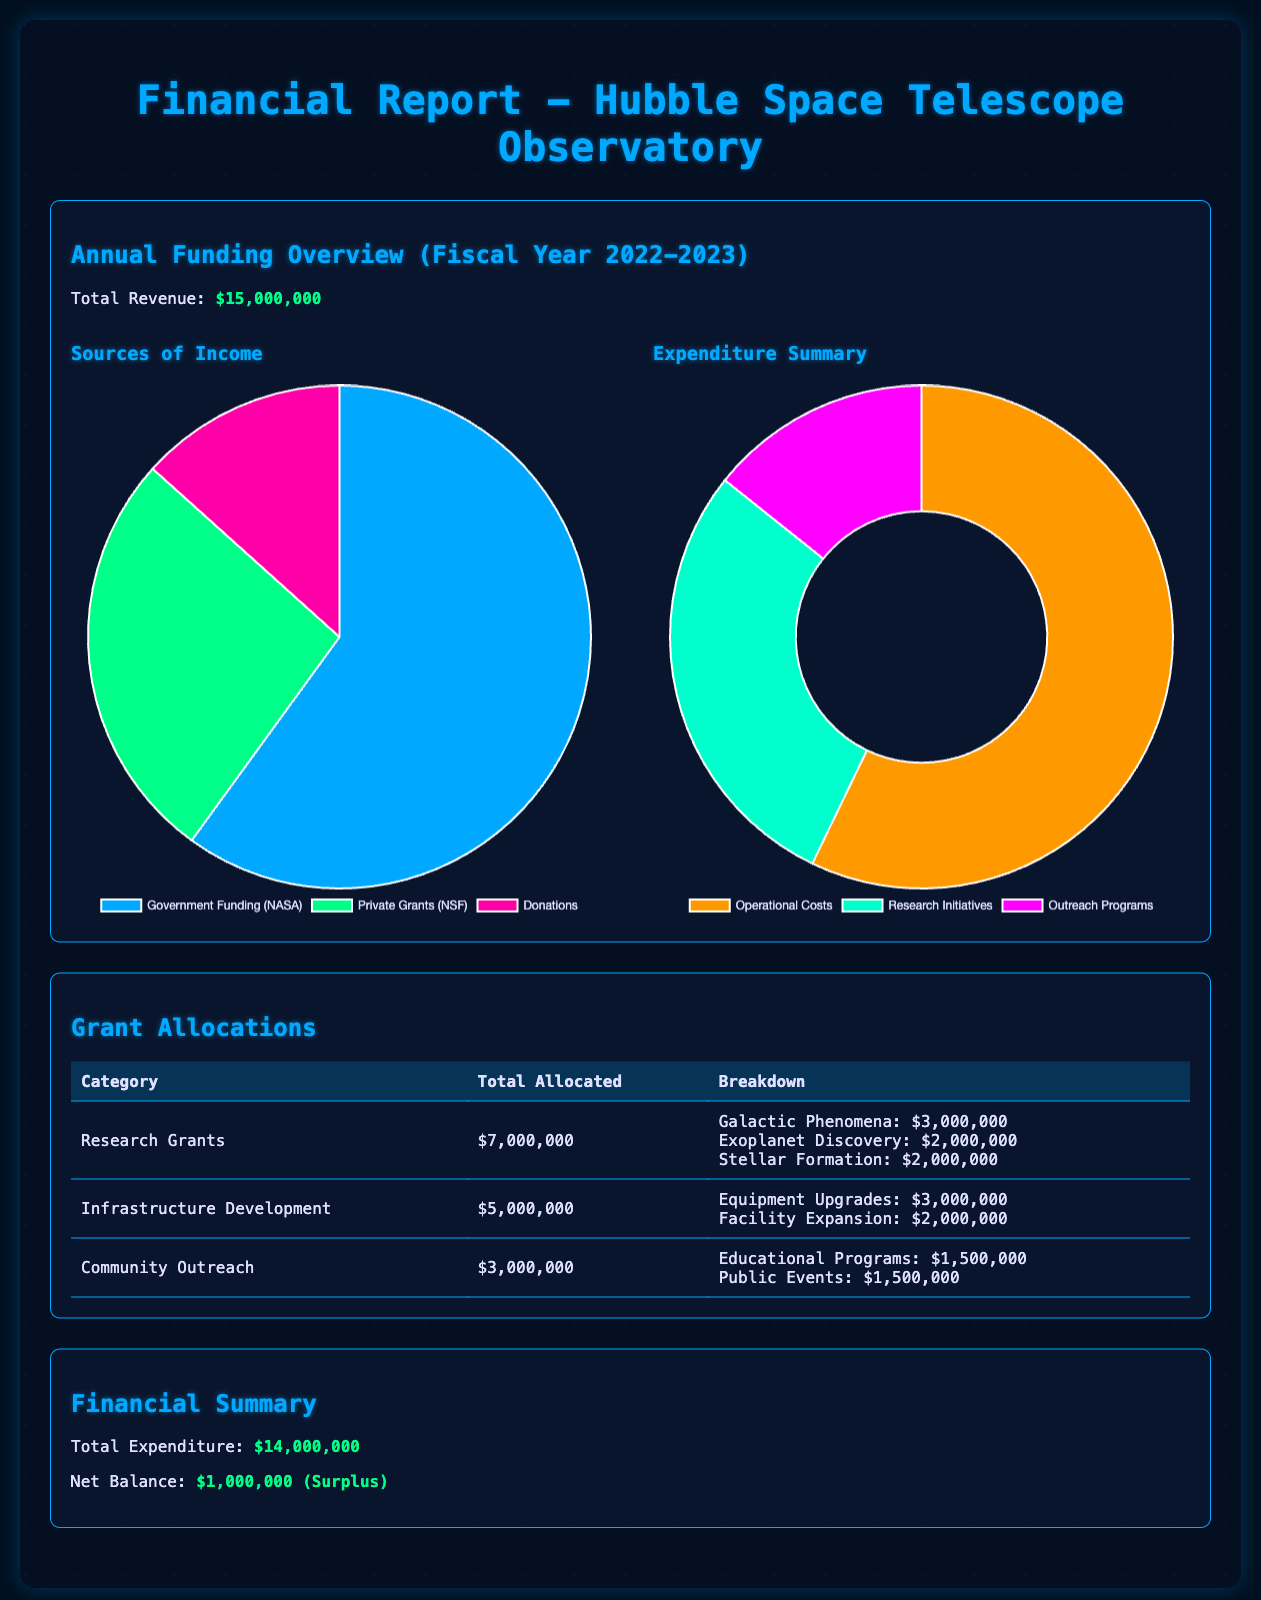What is the total revenue? The total revenue is explicitly stated in the document, which totals $15,000,000.
Answer: $15,000,000 How much is allocated for Research Grants? The document provides a breakdown of grant allocations, stating that Research Grants are allocated $7,000,000.
Answer: $7,000,000 What is the surplus for the fiscal year? The surplus is derived from the total revenue minus total expenditure; the document explicitly mentions the net balance is $1,000,000 (Surplus).
Answer: $1,000,000 (Surplus) Which category has the highest allocated amount? By comparing the total allocated amounts in the Grant Allocations section, Infrastructure Development has the highest allocation at $5,000,000.
Answer: Infrastructure Development What are the main sources of income? The document outlines sources of income, which include Government Funding (NASA), Private Grants (NSF), and Donations.
Answer: Government Funding, Private Grants, Donations How much is spent on Operational Costs? The expenditure summary displays the operational costs of the observatory amounting to $8,000,000.
Answer: $8,000,000 What percentage of total revenue does Community Outreach represent? To find this, we take the total allocated for Community Outreach ($3,000,000) as a percentage of total revenue ($15,000,000), which calculates to 20%.
Answer: 20% What is the total expenditure for the fiscal year? The total expenditure is clearly listed in the financial summary of the document as $14,000,000.
Answer: $14,000,000 What funding source contributed the most? The income chart indicates that Government Funding (NASA) contributed the largest share, amounting to $9,000,000.
Answer: Government Funding (NASA) 